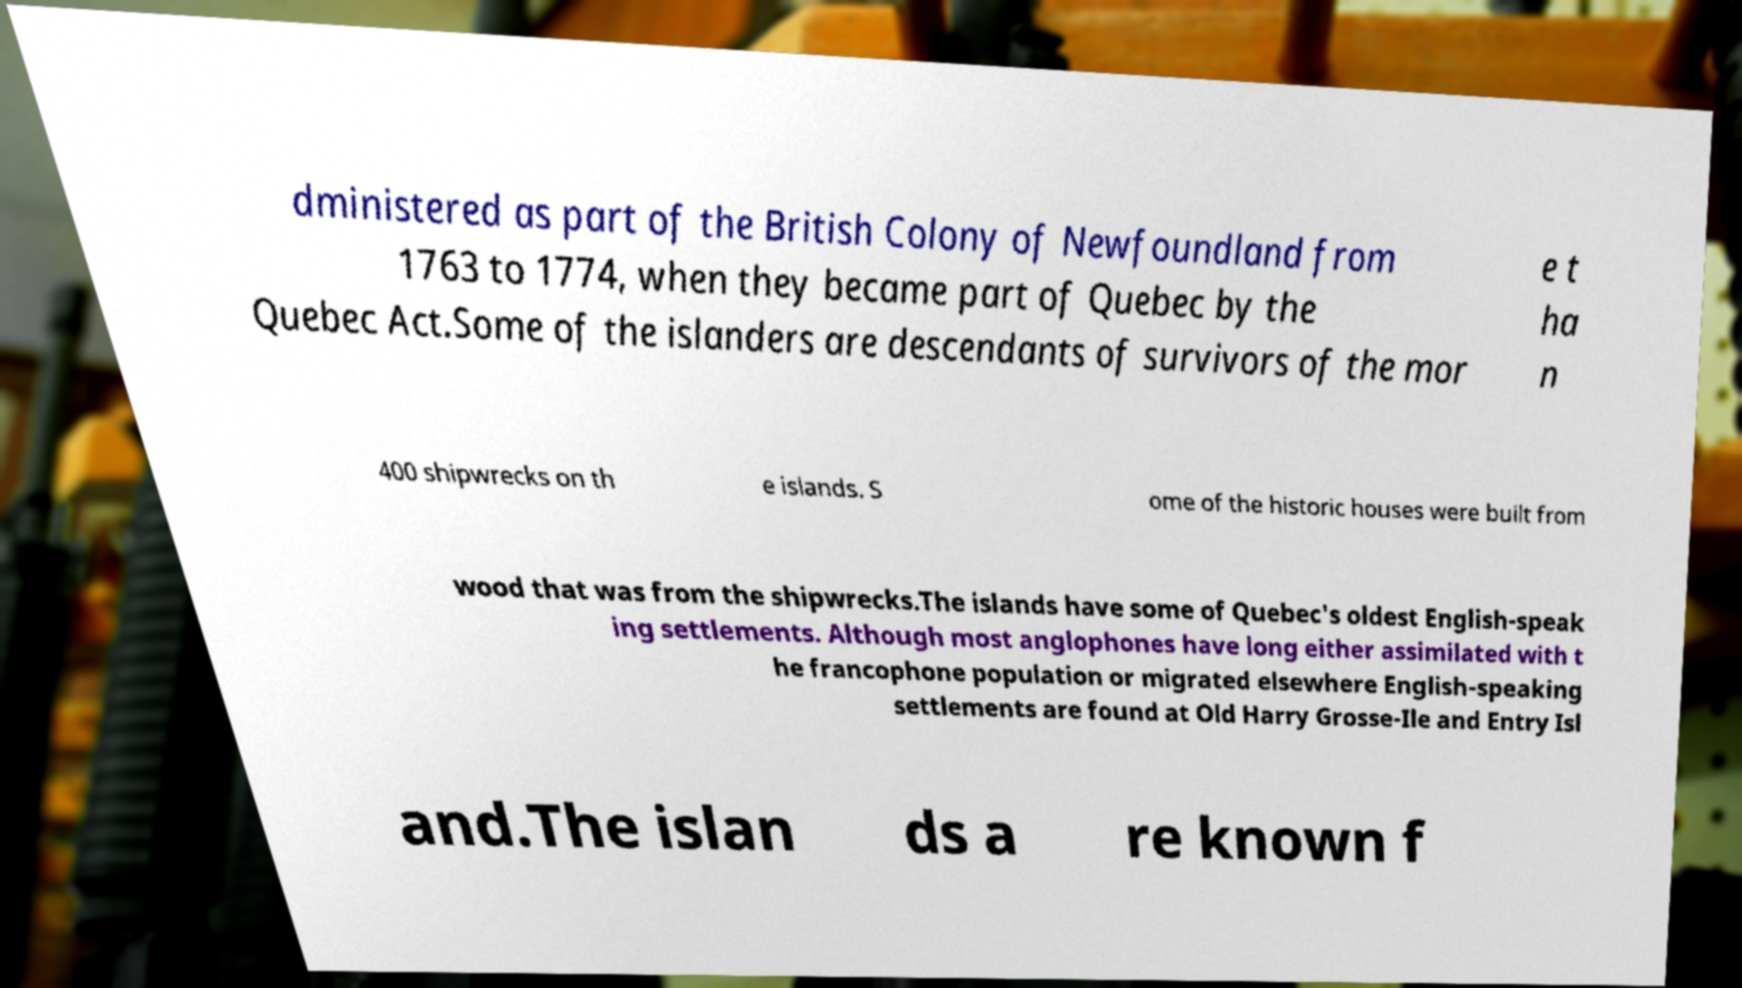Can you read and provide the text displayed in the image?This photo seems to have some interesting text. Can you extract and type it out for me? dministered as part of the British Colony of Newfoundland from 1763 to 1774, when they became part of Quebec by the Quebec Act.Some of the islanders are descendants of survivors of the mor e t ha n 400 shipwrecks on th e islands. S ome of the historic houses were built from wood that was from the shipwrecks.The islands have some of Quebec's oldest English-speak ing settlements. Although most anglophones have long either assimilated with t he francophone population or migrated elsewhere English-speaking settlements are found at Old Harry Grosse-Ile and Entry Isl and.The islan ds a re known f 